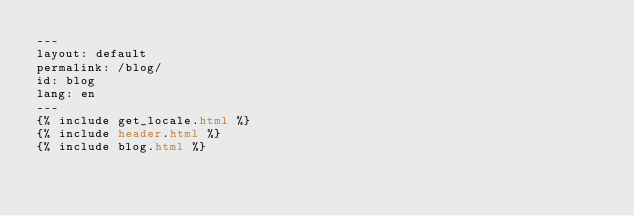Convert code to text. <code><loc_0><loc_0><loc_500><loc_500><_HTML_>---
layout: default
permalink: /blog/
id: blog
lang: en
---
{% include get_locale.html %}
{% include header.html %}
{% include blog.html %}
</code> 